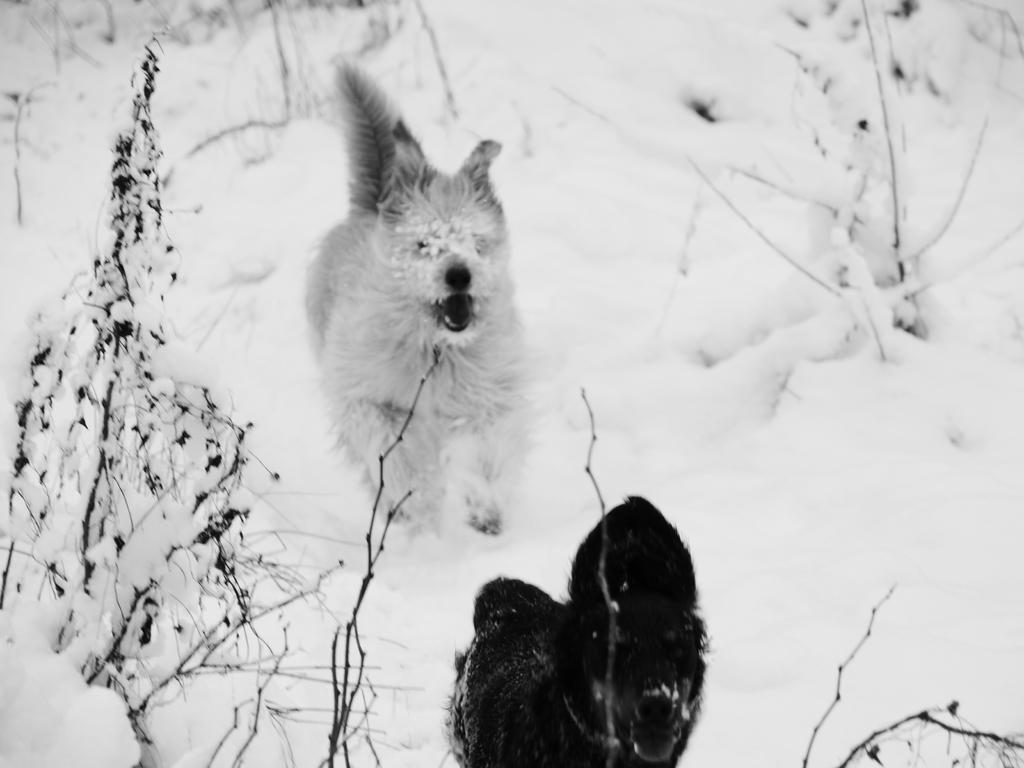How many dogs are present in the image? There are two dogs in the image. What is the setting or environment in which the dogs are located? The dogs are in the snow. What type of stem can be seen growing from the dogs in the image? There are no stems present in the image, as the main subjects are dogs and not plants. 